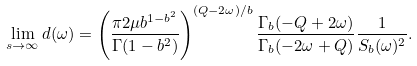<formula> <loc_0><loc_0><loc_500><loc_500>\lim _ { s \to \infty } d ( \omega ) = \left ( \frac { \pi 2 \mu b ^ { 1 - b ^ { 2 } } } { \Gamma ( 1 - b ^ { 2 } ) } \right ) ^ { ( Q - 2 \omega ) / b } \frac { \Gamma _ { b } ( - Q + 2 \omega ) } { \Gamma _ { b } ( - 2 \omega + Q ) } \frac { 1 } { S _ { b } ( \omega ) ^ { 2 } } .</formula> 